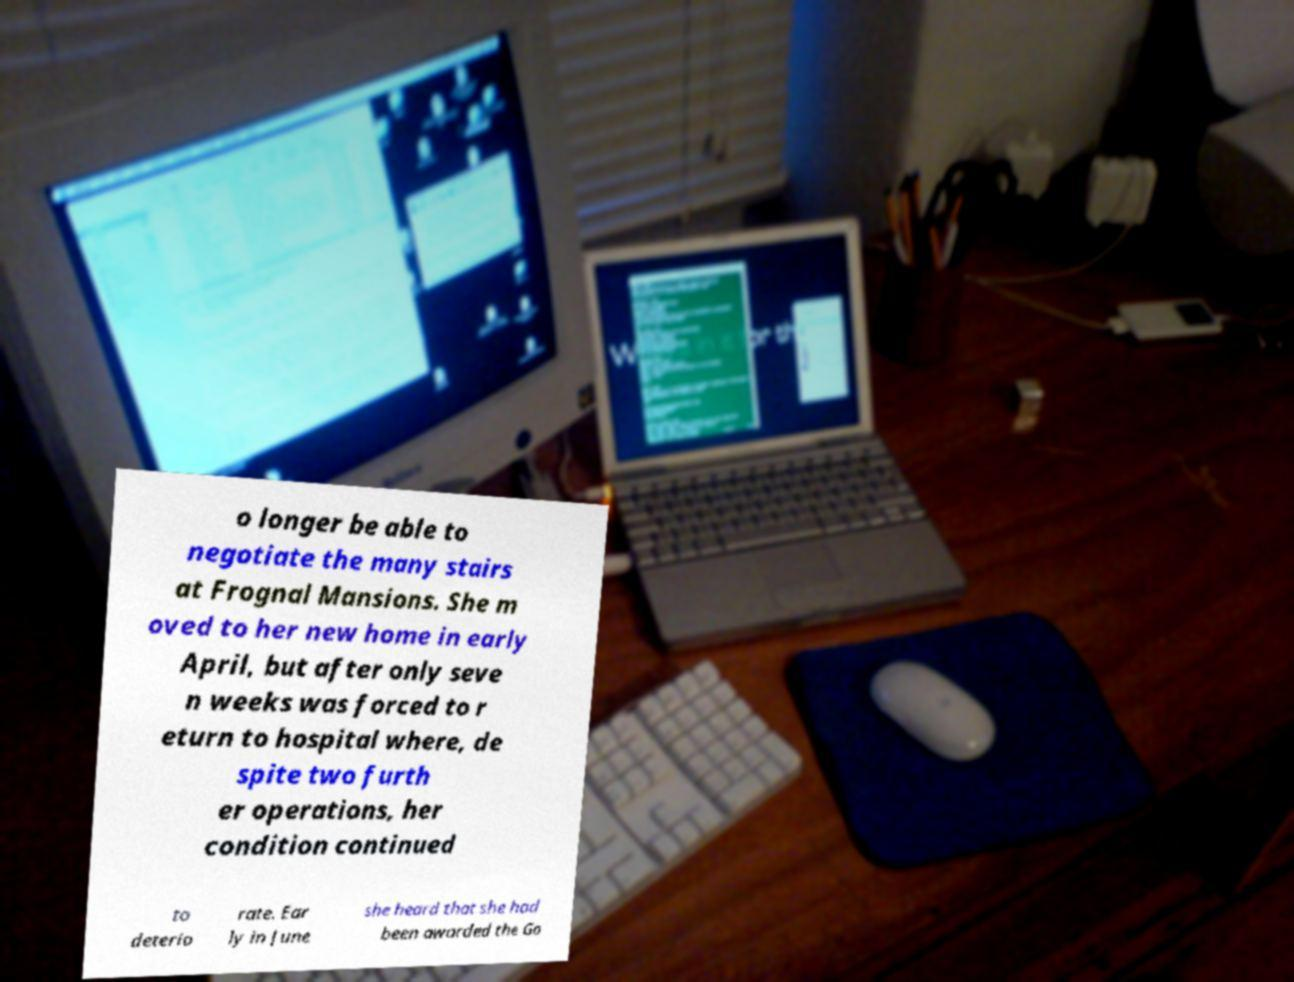What messages or text are displayed in this image? I need them in a readable, typed format. o longer be able to negotiate the many stairs at Frognal Mansions. She m oved to her new home in early April, but after only seve n weeks was forced to r eturn to hospital where, de spite two furth er operations, her condition continued to deterio rate. Ear ly in June she heard that she had been awarded the Go 